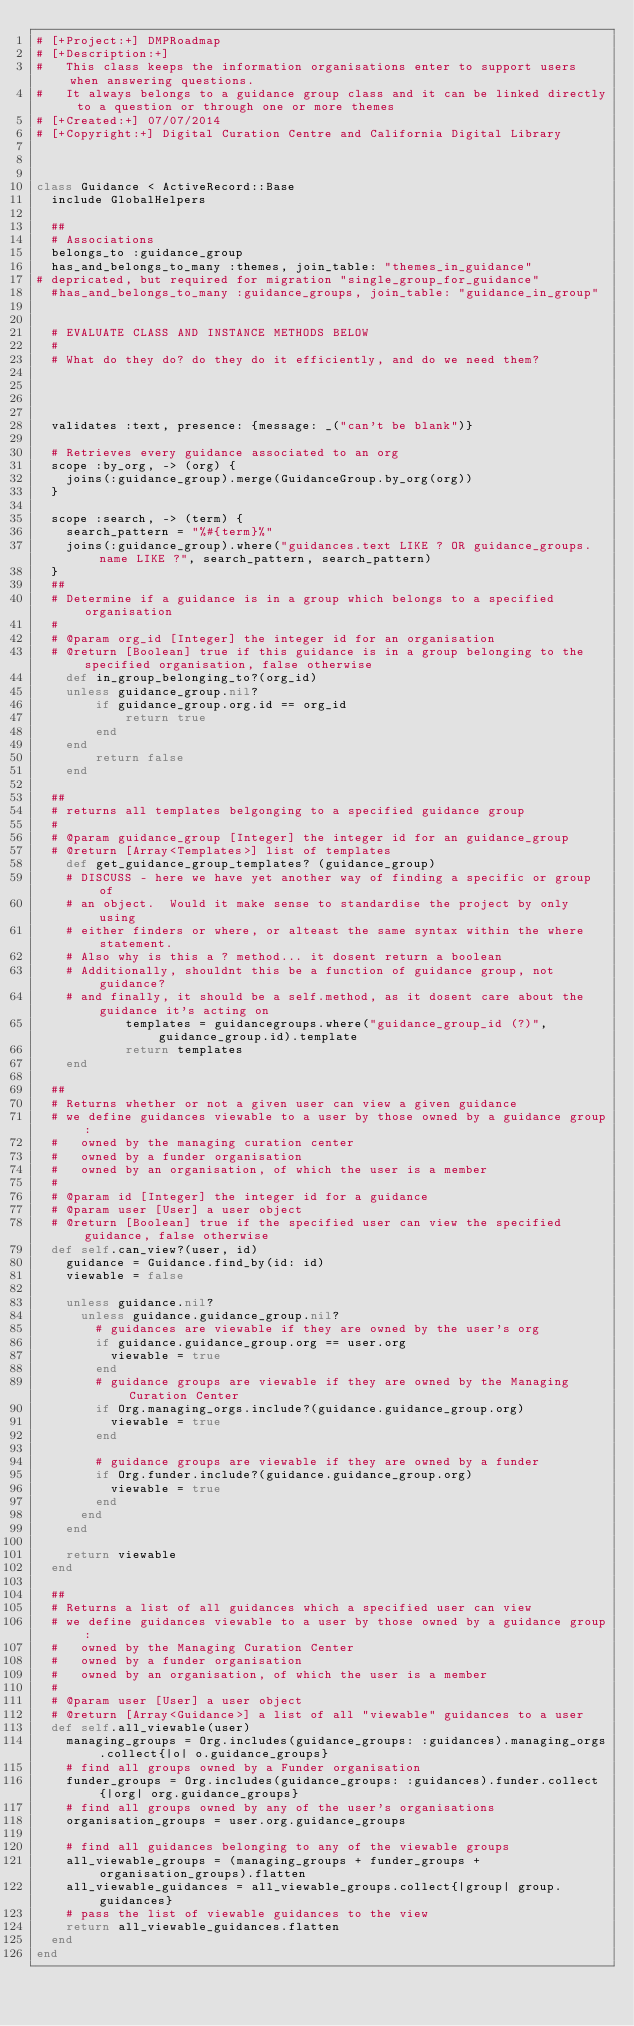<code> <loc_0><loc_0><loc_500><loc_500><_Ruby_># [+Project:+] DMPRoadmap
# [+Description:+]
#   This class keeps the information organisations enter to support users when answering questions.
#   It always belongs to a guidance group class and it can be linked directly to a question or through one or more themes
# [+Created:+] 07/07/2014
# [+Copyright:+] Digital Curation Centre and California Digital Library



class Guidance < ActiveRecord::Base
  include GlobalHelpers

  ##
  # Associations
  belongs_to :guidance_group
  has_and_belongs_to_many :themes, join_table: "themes_in_guidance"
# depricated, but required for migration "single_group_for_guidance"
  #has_and_belongs_to_many :guidance_groups, join_table: "guidance_in_group"


  # EVALUATE CLASS AND INSTANCE METHODS BELOW
  #
  # What do they do? do they do it efficiently, and do we need them?




  validates :text, presence: {message: _("can't be blank")}

  # Retrieves every guidance associated to an org
  scope :by_org, -> (org) {
    joins(:guidance_group).merge(GuidanceGroup.by_org(org))
  }

  scope :search, -> (term) {
    search_pattern = "%#{term}%"
    joins(:guidance_group).where("guidances.text LIKE ? OR guidance_groups.name LIKE ?", search_pattern, search_pattern)
  }
  ##
  # Determine if a guidance is in a group which belongs to a specified organisation
  #
  # @param org_id [Integer] the integer id for an organisation
  # @return [Boolean] true if this guidance is in a group belonging to the specified organisation, false otherwise
	def in_group_belonging_to?(org_id)
    unless guidance_group.nil?
  		if guidance_group.org.id == org_id
  			return true
  		end
    end
		return false
	end

  ##
  # returns all templates belgonging to a specified guidance group
  #
  # @param guidance_group [Integer] the integer id for an guidance_group
  # @return [Array<Templates>] list of templates
	def get_guidance_group_templates? (guidance_group)
    # DISCUSS - here we have yet another way of finding a specific or group of
    # an object.  Would it make sense to standardise the project by only using
    # either finders or where, or alteast the same syntax within the where statement.
    # Also why is this a ? method... it dosent return a boolean
    # Additionally, shouldnt this be a function of guidance group, not guidance?
    # and finally, it should be a self.method, as it dosent care about the guidance it's acting on
			templates = guidancegroups.where("guidance_group_id (?)", guidance_group.id).template
			return templates
	end

  ##
  # Returns whether or not a given user can view a given guidance
  # we define guidances viewable to a user by those owned by a guidance group:
  #   owned by the managing curation center
  #   owned by a funder organisation
  #   owned by an organisation, of which the user is a member
  #
  # @param id [Integer] the integer id for a guidance
  # @param user [User] a user object
  # @return [Boolean] true if the specified user can view the specified guidance, false otherwise
  def self.can_view?(user, id)
    guidance = Guidance.find_by(id: id)
    viewable = false

    unless guidance.nil?
      unless guidance.guidance_group.nil?
        # guidances are viewable if they are owned by the user's org
        if guidance.guidance_group.org == user.org
          viewable = true
        end
        # guidance groups are viewable if they are owned by the Managing Curation Center
        if Org.managing_orgs.include?(guidance.guidance_group.org)
          viewable = true
        end

        # guidance groups are viewable if they are owned by a funder
        if Org.funder.include?(guidance.guidance_group.org)
          viewable = true
        end
      end
    end

    return viewable
  end

  ##
  # Returns a list of all guidances which a specified user can view
  # we define guidances viewable to a user by those owned by a guidance group:
  #   owned by the Managing Curation Center
  #   owned by a funder organisation
  #   owned by an organisation, of which the user is a member
  #
  # @param user [User] a user object
  # @return [Array<Guidance>] a list of all "viewable" guidances to a user
  def self.all_viewable(user)
    managing_groups = Org.includes(guidance_groups: :guidances).managing_orgs.collect{|o| o.guidance_groups}
    # find all groups owned by a Funder organisation
    funder_groups = Org.includes(guidance_groups: :guidances).funder.collect{|org| org.guidance_groups}
    # find all groups owned by any of the user's organisations
    organisation_groups = user.org.guidance_groups

    # find all guidances belonging to any of the viewable groups
    all_viewable_groups = (managing_groups + funder_groups + organisation_groups).flatten
    all_viewable_guidances = all_viewable_groups.collect{|group| group.guidances}
    # pass the list of viewable guidances to the view
    return all_viewable_guidances.flatten
  end
end
</code> 